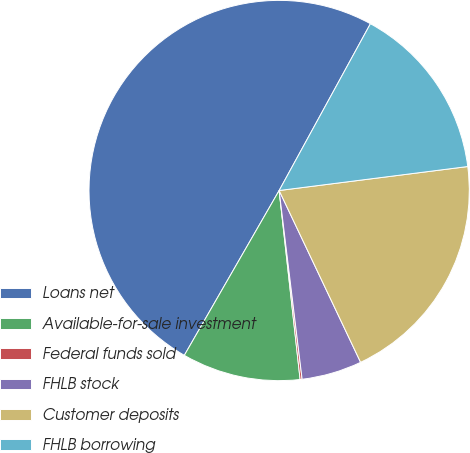Convert chart. <chart><loc_0><loc_0><loc_500><loc_500><pie_chart><fcel>Loans net<fcel>Available-for-sale investment<fcel>Federal funds sold<fcel>FHLB stock<fcel>Customer deposits<fcel>FHLB borrowing<nl><fcel>49.67%<fcel>10.07%<fcel>0.17%<fcel>5.12%<fcel>19.97%<fcel>15.02%<nl></chart> 